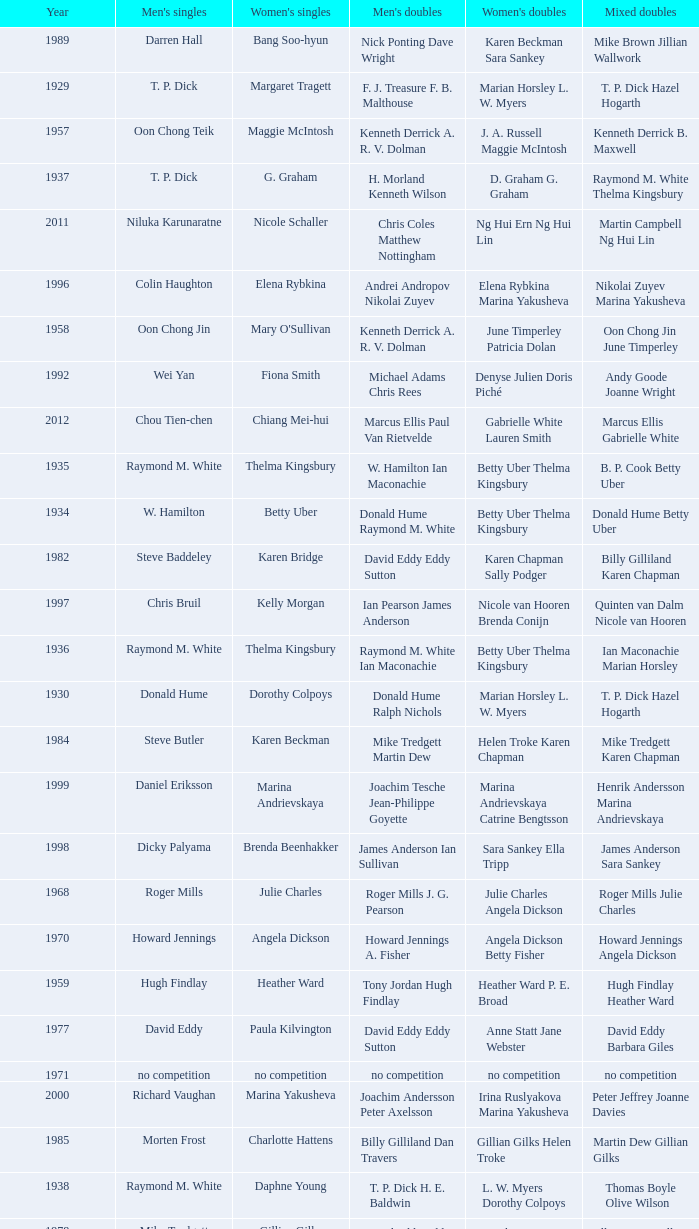Who won the Women's doubles in the year that David Eddy Eddy Sutton won the Men's doubles, and that David Eddy won the Men's singles? Anne Statt Jane Webster. 